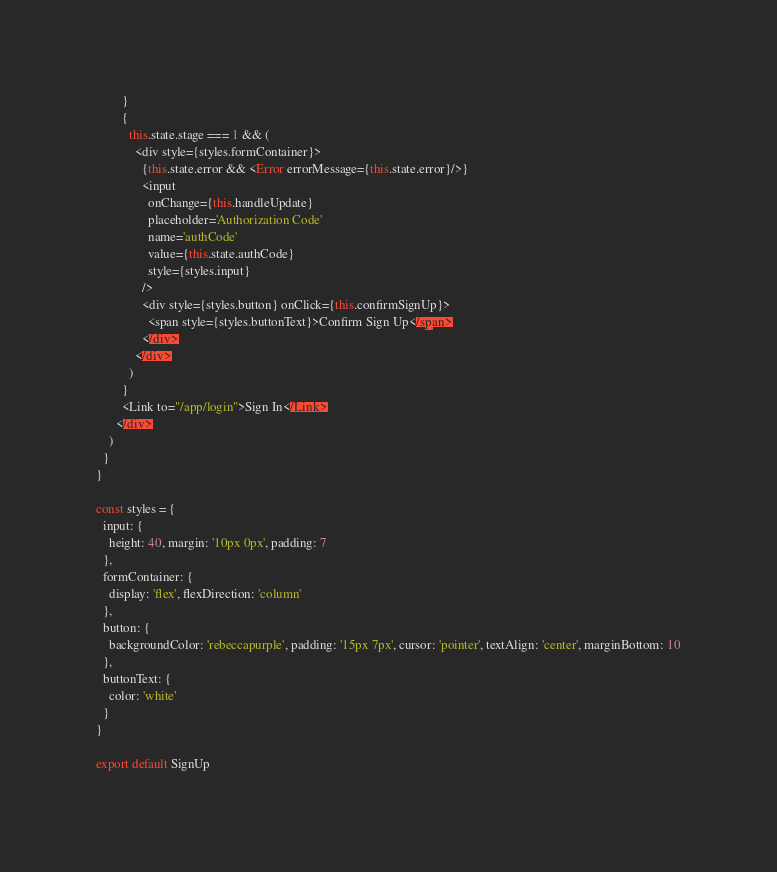Convert code to text. <code><loc_0><loc_0><loc_500><loc_500><_JavaScript_>        }
        {
          this.state.stage === 1 && (
            <div style={styles.formContainer}>
              {this.state.error && <Error errorMessage={this.state.error}/>}
              <input
                onChange={this.handleUpdate}
                placeholder='Authorization Code'
                name='authCode'
                value={this.state.authCode}
                style={styles.input}
              />
              <div style={styles.button} onClick={this.confirmSignUp}>
                <span style={styles.buttonText}>Confirm Sign Up</span>
              </div>
            </div>
          )
        }
        <Link to="/app/login">Sign In</Link>
      </div>
    )
  }
}

const styles = {
  input: {
    height: 40, margin: '10px 0px', padding: 7
  },
  formContainer: {
    display: 'flex', flexDirection: 'column'
  },
  button: {
    backgroundColor: 'rebeccapurple', padding: '15px 7px', cursor: 'pointer', textAlign: 'center', marginBottom: 10
  },
  buttonText: {
    color: 'white'
  }
}

export default SignUp</code> 